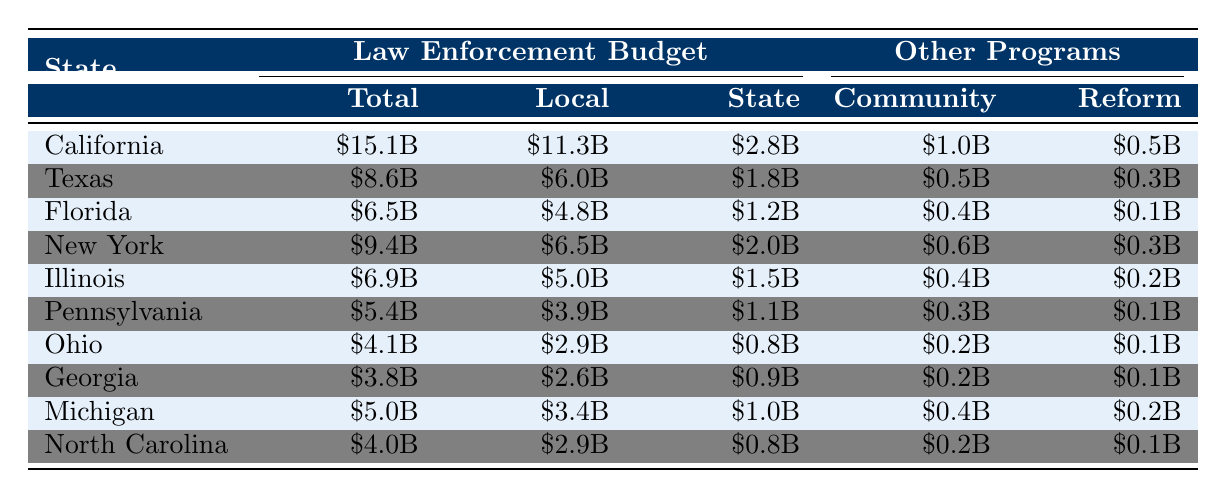What is the total law enforcement budget for California? The table shows that California has a total law enforcement budget of $15.1 billion.
Answer: $15.1 billion Which state has the highest budget allocation for community programs? According to the table, California has the highest allocation for community programs at $1.0 billion compared to other states.
Answer: California What is the total law enforcement budget for Texas and Florida combined? To find the combined budget, add Texas' budget of $8.6 billion and Florida's budget of $6.5 billion: 8.6 + 6.5 = 15.1 billion.
Answer: $15.1 billion Is Georgia's total law enforcement budget greater than that of Ohio? The table indicates Georgia's budget is $3.8 billion, while Ohio's budget is $4.1 billion. Thus, Georgia's budget is less than Ohio's.
Answer: No What is the average budget for state law enforcement across the listed states? Add the state law enforcement budgets: 2.8 (California) + 1.8 (Texas) + 1.2 (Florida) + 2.0 (New York) + 1.5 (Illinois) + 1.1 (Pennsylvania) + 0.8 (Ohio) + 0.9 (Georgia) + 1.0 (Michigan) + 0.8 (North Carolina) = 13.1 billion. Then divide by 10 states to find the average: 13.1 / 10 = 1.31 billion.
Answer: $1.31 billion Which state has the lowest budget for criminal justice reform? By examining the table, I find that both Florida and Pennsylvania allocate $0.1 billion for criminal justice reform, which is the lowest amount indicated.
Answer: Florida and Pennsylvania What is the difference in local law enforcement budgets between New York and Illinois? The local law enforcement budget for New York is $6.5 billion and for Illinois is $5.0 billion. The difference is 6.5 - 5.0 = 1.5 billion.
Answer: $1.5 billion How much does North Carolina allocate for community programs and criminal justice reform combined? Adding North Carolina's community programs budget of $0.2 billion and criminal justice reform budget of $0.1 billion gives us 0.2 + 0.1 = 0.3 billion.
Answer: $0.3 billion Is the total law enforcement budget for California more than the sum of the budgets for Texas and Florida? The total for California is $15.1 billion, while Texas and Florida combined total $15.1 billion. Therefore, California does not exceed this sum.
Answer: No What percentage of California's total budget is allocated to community programs? To find the percentage, divide California's community program budget of $1.0 billion by the total budget of $15.1 billion: (1.0 / 15.1) * 100 = approximately 6.62%.
Answer: Approximately 6.62% Which state has the largest local law enforcement budget, and what is that amount? Reviewing the table, California has the largest local law enforcement budget of $11.3 billion.
Answer: California, $11.3 billion 